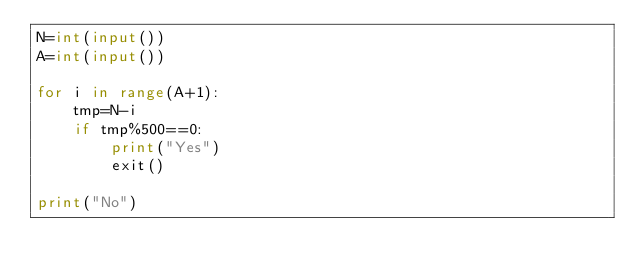Convert code to text. <code><loc_0><loc_0><loc_500><loc_500><_Python_>N=int(input())
A=int(input())

for i in range(A+1):
    tmp=N-i
    if tmp%500==0:
        print("Yes")
        exit()

print("No")
</code> 